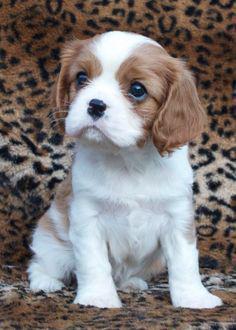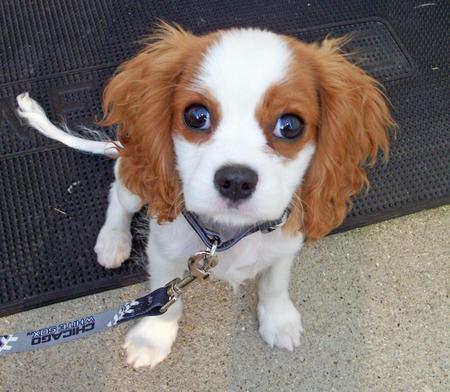The first image is the image on the left, the second image is the image on the right. Assess this claim about the two images: "One image contains twice as many spaniel pups as the other, and one image includes a hand holding a puppy.". Correct or not? Answer yes or no. No. The first image is the image on the left, the second image is the image on the right. For the images shown, is this caption "The left image contains exactly two dogs." true? Answer yes or no. No. 